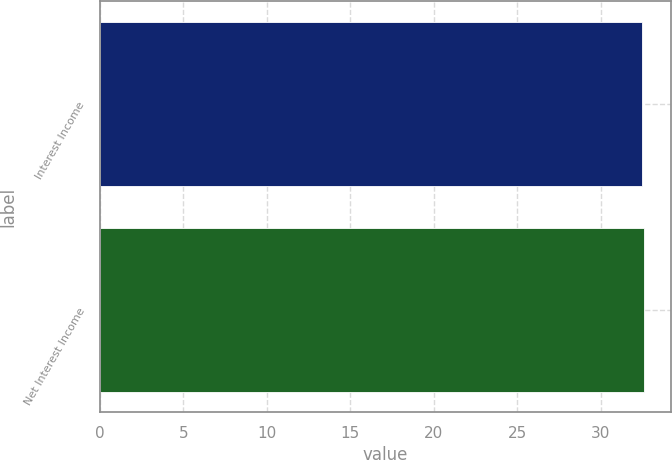Convert chart. <chart><loc_0><loc_0><loc_500><loc_500><bar_chart><fcel>Interest Income<fcel>Net Interest Income<nl><fcel>32.5<fcel>32.6<nl></chart> 